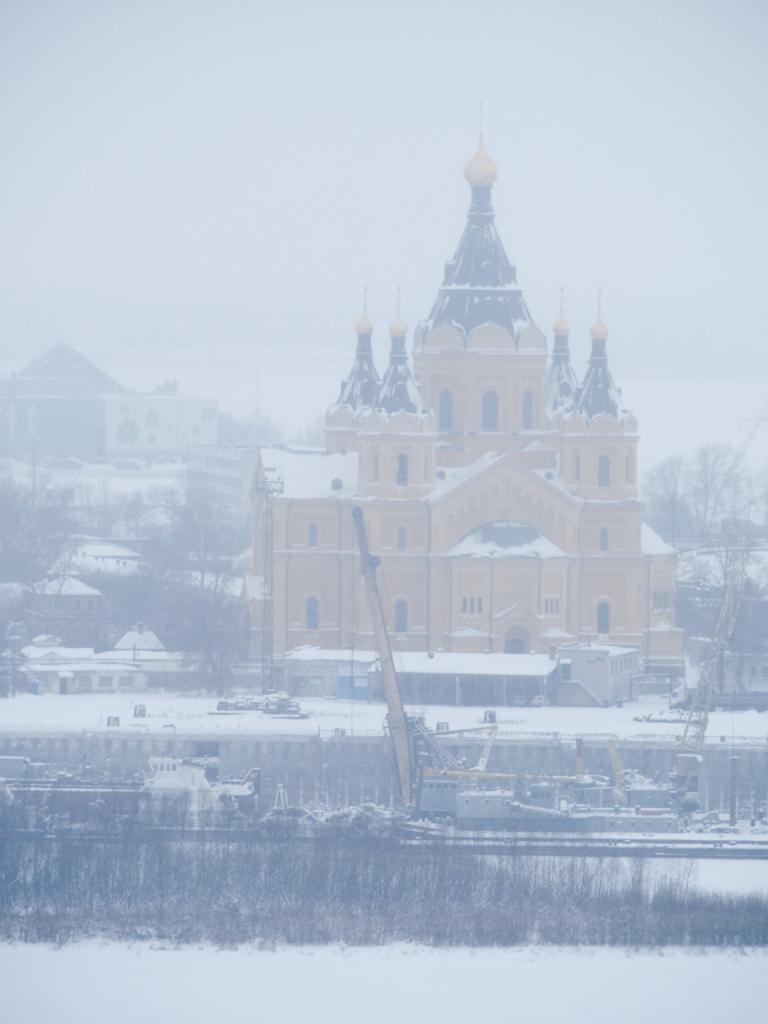Could you give a brief overview of what you see in this image? In this image we can see the buildings, houses, trees, cranes and also grass and the image is fully covered with the snow. 